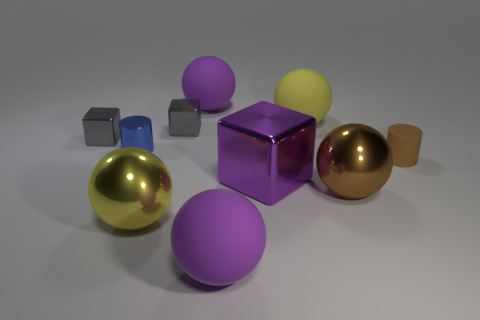Subtract all big purple balls. How many balls are left? 3 Subtract all cyan spheres. How many gray cubes are left? 2 Subtract 3 balls. How many balls are left? 2 Subtract all brown balls. How many balls are left? 4 Subtract all blocks. How many objects are left? 7 Subtract all brown objects. Subtract all big spheres. How many objects are left? 3 Add 3 large spheres. How many large spheres are left? 8 Add 2 small gray metal cubes. How many small gray metal cubes exist? 4 Subtract 0 cyan cubes. How many objects are left? 10 Subtract all blue balls. Subtract all red cylinders. How many balls are left? 5 